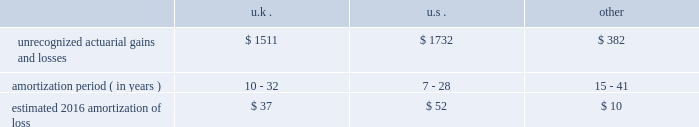Loss on the contract may be recorded , if necessary , and any remaining deferred implementation revenues would typically be recognized over the remaining service period through the termination date .
In connection with our long-term outsourcing service agreements , highly customized implementation efforts are often necessary to set up clients and their human resource or benefit programs on our systems and operating processes .
For outsourcing services sold separately or accounted for as a separate unit of accounting , specific , incremental and direct costs of implementation incurred prior to the services commencing are generally deferred and amortized over the period that the related ongoing services revenue is recognized .
Deferred costs are assessed for recoverability on a periodic basis to the extent the deferred cost exceeds related deferred revenue .
Pensions we sponsor defined benefit pension plans throughout the world .
Our most significant plans are located in the u.s. , the u.k. , the netherlands and canada .
Our significant u.s. , u.k. , netherlands and canadian pension plans are closed to new entrants .
We have ceased crediting future benefits relating to salary and service for our u.s. , u.k. , netherlands and canadian plans to the extent statutorily permitted .
In 2016 , we estimate pension and post-retirement net periodic benefit cost for major plans to increase by $ 15 million to a benefit of approximately $ 54 million .
The increase in the benefit is primarily due to a change in our approach to measuring service and interest cost .
Effective december 31 , 2015 and for 2016 expense , we have elected to utilize a full yield curve approach in the estimation of the service and interest cost components of net periodic pension and post-retirement benefit cost for our major pension and other post-retirement benefit plans by applying the specific spot rates along the yield curve used in the determination of the benefit obligation to the relevant projected cash flows .
In 2015 and prior years , we estimated these components of net periodic pension and post-retirement benefit cost by applying a single weighted-average discount rate , derived from the yield curve used to measure the benefit obligation at the beginning of the period .
We have made this change to improve the correlation between projected benefit cash flows and the corresponding yield curve spot rates and to provide a more precise measurement of service and interest costs .
This change does not affect the measurement of the projected benefit obligation as the change in the service cost and interest cost is completely offset in the actuarial ( gain ) loss recorded in other comprehensive income .
We accounted for this change as a change in estimate and , accordingly , will account for it prospectively .
Recognition of gains and losses and prior service certain changes in the value of the obligation and in the value of plan assets , which may occur due to various factors such as changes in the discount rate and actuarial assumptions , actual demographic experience and/or plan asset performance are not immediately recognized in net income .
Such changes are recognized in other comprehensive income and are amortized into net income as part of the net periodic benefit cost .
Unrecognized gains and losses that have been deferred in other comprehensive income , as previously described , are amortized into compensation and benefits expense as a component of periodic pension expense based on the average life expectancy of the u.s. , the netherlands , canada , and u.k .
Plan members .
We amortize any prior service expense or credits that arise as a result of plan changes over a period consistent with the amortization of gains and losses .
As of december 31 , 2015 , our pension plans have deferred losses that have not yet been recognized through income in the consolidated financial statements .
We amortize unrecognized actuarial losses outside of a corridor , which is defined as 10% ( 10 % ) of the greater of market-related value of plan assets or projected benefit obligation .
To the extent not offset by future gains , incremental amortization as calculated above will continue to affect future pension expense similarly until fully amortized .
The table discloses our unrecognized actuarial gains and losses , the number of years over which we are amortizing the experience loss , and the estimated 2016 amortization of loss by country ( amounts in millions ) : .
The unrecognized prior service cost ( income ) at december 31 , 2015 was $ 9 million , $ 46 million , and $ ( 7 ) million in the u.s. , u.k .
And other plans , respectively .
For the u.s .
Pension plans we use a market-related valuation of assets approach to determine the expected return on assets , which is a component of net periodic benefit cost recognized in the consolidated statements of income .
This approach .
What was the ratio of the uk unrecognized actuarial gains and losses to the us in 2016? 
Computations: (1511 / 1732)
Answer: 0.8724. Loss on the contract may be recorded , if necessary , and any remaining deferred implementation revenues would typically be recognized over the remaining service period through the termination date .
In connection with our long-term outsourcing service agreements , highly customized implementation efforts are often necessary to set up clients and their human resource or benefit programs on our systems and operating processes .
For outsourcing services sold separately or accounted for as a separate unit of accounting , specific , incremental and direct costs of implementation incurred prior to the services commencing are generally deferred and amortized over the period that the related ongoing services revenue is recognized .
Deferred costs are assessed for recoverability on a periodic basis to the extent the deferred cost exceeds related deferred revenue .
Pensions we sponsor defined benefit pension plans throughout the world .
Our most significant plans are located in the u.s. , the u.k. , the netherlands and canada .
Our significant u.s. , u.k. , netherlands and canadian pension plans are closed to new entrants .
We have ceased crediting future benefits relating to salary and service for our u.s. , u.k. , netherlands and canadian plans to the extent statutorily permitted .
In 2016 , we estimate pension and post-retirement net periodic benefit cost for major plans to increase by $ 15 million to a benefit of approximately $ 54 million .
The increase in the benefit is primarily due to a change in our approach to measuring service and interest cost .
Effective december 31 , 2015 and for 2016 expense , we have elected to utilize a full yield curve approach in the estimation of the service and interest cost components of net periodic pension and post-retirement benefit cost for our major pension and other post-retirement benefit plans by applying the specific spot rates along the yield curve used in the determination of the benefit obligation to the relevant projected cash flows .
In 2015 and prior years , we estimated these components of net periodic pension and post-retirement benefit cost by applying a single weighted-average discount rate , derived from the yield curve used to measure the benefit obligation at the beginning of the period .
We have made this change to improve the correlation between projected benefit cash flows and the corresponding yield curve spot rates and to provide a more precise measurement of service and interest costs .
This change does not affect the measurement of the projected benefit obligation as the change in the service cost and interest cost is completely offset in the actuarial ( gain ) loss recorded in other comprehensive income .
We accounted for this change as a change in estimate and , accordingly , will account for it prospectively .
Recognition of gains and losses and prior service certain changes in the value of the obligation and in the value of plan assets , which may occur due to various factors such as changes in the discount rate and actuarial assumptions , actual demographic experience and/or plan asset performance are not immediately recognized in net income .
Such changes are recognized in other comprehensive income and are amortized into net income as part of the net periodic benefit cost .
Unrecognized gains and losses that have been deferred in other comprehensive income , as previously described , are amortized into compensation and benefits expense as a component of periodic pension expense based on the average life expectancy of the u.s. , the netherlands , canada , and u.k .
Plan members .
We amortize any prior service expense or credits that arise as a result of plan changes over a period consistent with the amortization of gains and losses .
As of december 31 , 2015 , our pension plans have deferred losses that have not yet been recognized through income in the consolidated financial statements .
We amortize unrecognized actuarial losses outside of a corridor , which is defined as 10% ( 10 % ) of the greater of market-related value of plan assets or projected benefit obligation .
To the extent not offset by future gains , incremental amortization as calculated above will continue to affect future pension expense similarly until fully amortized .
The table discloses our unrecognized actuarial gains and losses , the number of years over which we are amortizing the experience loss , and the estimated 2016 amortization of loss by country ( amounts in millions ) : .
The unrecognized prior service cost ( income ) at december 31 , 2015 was $ 9 million , $ 46 million , and $ ( 7 ) million in the u.s. , u.k .
And other plans , respectively .
For the u.s .
Pension plans we use a market-related valuation of assets approach to determine the expected return on assets , which is a component of net periodic benefit cost recognized in the consolidated statements of income .
This approach .
In 2015 what was the ratio of the unrecognized prior service cost to the income? 
Computations: (7 / (9 + 46))
Answer: 0.12727. 